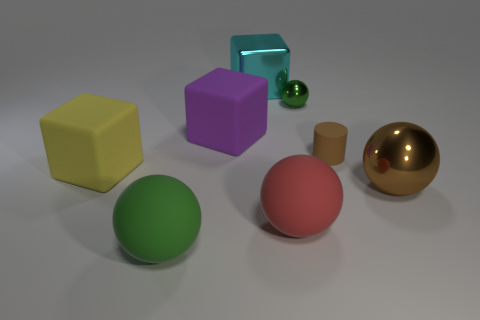Add 1 small gray matte cubes. How many objects exist? 9 Subtract all cubes. How many objects are left? 5 Subtract all red matte things. Subtract all yellow rubber things. How many objects are left? 6 Add 1 tiny brown rubber cylinders. How many tiny brown rubber cylinders are left? 2 Add 7 tiny yellow matte cylinders. How many tiny yellow matte cylinders exist? 7 Subtract 1 brown balls. How many objects are left? 7 